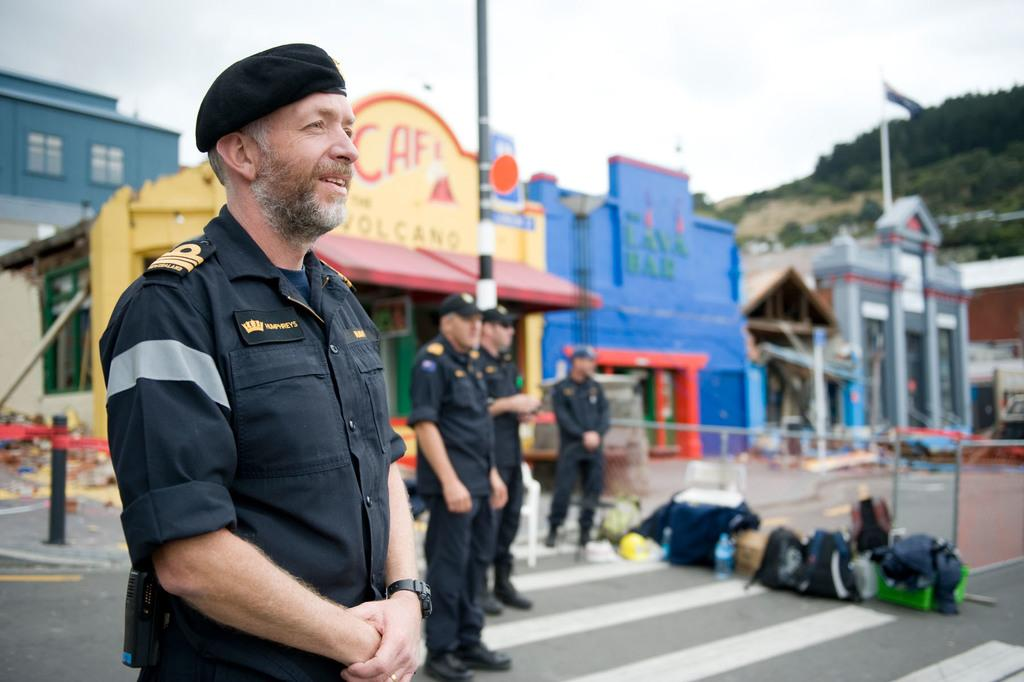What type of establishments can be seen in the image? There are stores in the image. Are there any people present in the image? Yes, there are people standing in the image. What type of natural elements can be seen in the image? There are trees in the image. What else can be seen on the ground in the image? There are objects placed on the road in the image. What type of mint is being used to care for the trees in the image? There is no mint or any indication of tree care in the image. What attempt can be seen being made by the people in the image? The image does not show any specific attempts or actions being taken by the people. 